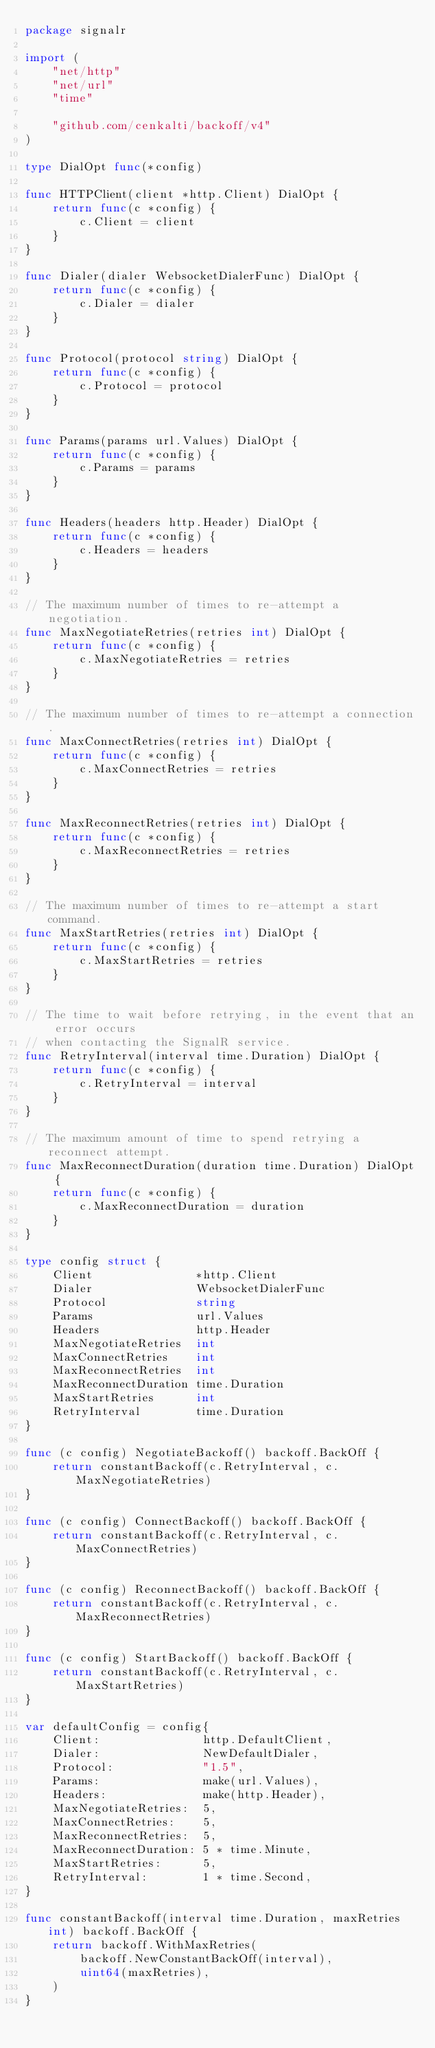Convert code to text. <code><loc_0><loc_0><loc_500><loc_500><_Go_>package signalr

import (
	"net/http"
	"net/url"
	"time"

	"github.com/cenkalti/backoff/v4"
)

type DialOpt func(*config)

func HTTPClient(client *http.Client) DialOpt {
	return func(c *config) {
		c.Client = client
	}
}

func Dialer(dialer WebsocketDialerFunc) DialOpt {
	return func(c *config) {
		c.Dialer = dialer
	}
}

func Protocol(protocol string) DialOpt {
	return func(c *config) {
		c.Protocol = protocol
	}
}

func Params(params url.Values) DialOpt {
	return func(c *config) {
		c.Params = params
	}
}

func Headers(headers http.Header) DialOpt {
	return func(c *config) {
		c.Headers = headers
	}
}

// The maximum number of times to re-attempt a negotiation.
func MaxNegotiateRetries(retries int) DialOpt {
	return func(c *config) {
		c.MaxNegotiateRetries = retries
	}
}

// The maximum number of times to re-attempt a connection.
func MaxConnectRetries(retries int) DialOpt {
	return func(c *config) {
		c.MaxConnectRetries = retries
	}
}

func MaxReconnectRetries(retries int) DialOpt {
	return func(c *config) {
		c.MaxReconnectRetries = retries
	}
}

// The maximum number of times to re-attempt a start command.
func MaxStartRetries(retries int) DialOpt {
	return func(c *config) {
		c.MaxStartRetries = retries
	}
}

// The time to wait before retrying, in the event that an error occurs
// when contacting the SignalR service.
func RetryInterval(interval time.Duration) DialOpt {
	return func(c *config) {
		c.RetryInterval = interval
	}
}

// The maximum amount of time to spend retrying a reconnect attempt.
func MaxReconnectDuration(duration time.Duration) DialOpt {
	return func(c *config) {
		c.MaxReconnectDuration = duration
	}
}

type config struct {
	Client               *http.Client
	Dialer               WebsocketDialerFunc
	Protocol             string
	Params               url.Values
	Headers              http.Header
	MaxNegotiateRetries  int
	MaxConnectRetries    int
	MaxReconnectRetries  int
	MaxReconnectDuration time.Duration
	MaxStartRetries      int
	RetryInterval        time.Duration
}

func (c config) NegotiateBackoff() backoff.BackOff {
	return constantBackoff(c.RetryInterval, c.MaxNegotiateRetries)
}

func (c config) ConnectBackoff() backoff.BackOff {
	return constantBackoff(c.RetryInterval, c.MaxConnectRetries)
}

func (c config) ReconnectBackoff() backoff.BackOff {
	return constantBackoff(c.RetryInterval, c.MaxReconnectRetries)
}

func (c config) StartBackoff() backoff.BackOff {
	return constantBackoff(c.RetryInterval, c.MaxStartRetries)
}

var defaultConfig = config{
	Client:               http.DefaultClient,
	Dialer:               NewDefaultDialer,
	Protocol:             "1.5",
	Params:               make(url.Values),
	Headers:              make(http.Header),
	MaxNegotiateRetries:  5,
	MaxConnectRetries:    5,
	MaxReconnectRetries:  5,
	MaxReconnectDuration: 5 * time.Minute,
	MaxStartRetries:      5,
	RetryInterval:        1 * time.Second,
}

func constantBackoff(interval time.Duration, maxRetries int) backoff.BackOff {
	return backoff.WithMaxRetries(
		backoff.NewConstantBackOff(interval),
		uint64(maxRetries),
	)
}
</code> 